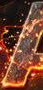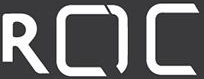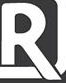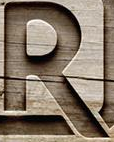What words can you see in these images in sequence, separated by a semicolon? #; ROC; R; R 